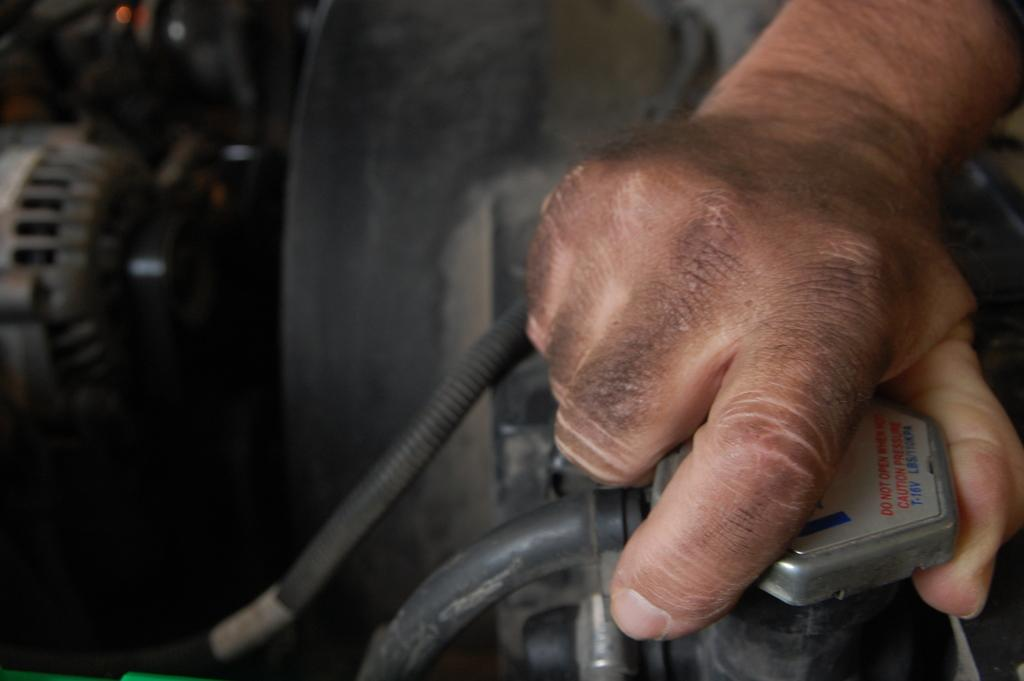What part of a person is visible in the image? There is a person's hand in the image. On which side of the image is the person's hand located? The person's hand is on the right side of the image. What is the person holding in the image? The person is holding something that looks like a motor. Where is the motor located in the image? The motor is on the left side of the image. Can you describe the background of the image? The background of the image is blurry. What type of attraction can be seen in the background of the image? There is no attraction visible in the background of the image; it is blurry. Is there a crate present in the image? There is no crate mentioned or visible in the image. 